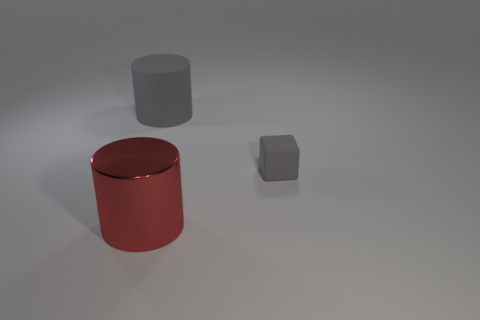Add 2 large red things. How many objects exist? 5 Subtract all cylinders. How many objects are left? 1 Add 3 large shiny objects. How many large shiny objects exist? 4 Subtract 0 brown cylinders. How many objects are left? 3 Subtract all gray matte things. Subtract all big brown rubber blocks. How many objects are left? 1 Add 2 rubber cylinders. How many rubber cylinders are left? 3 